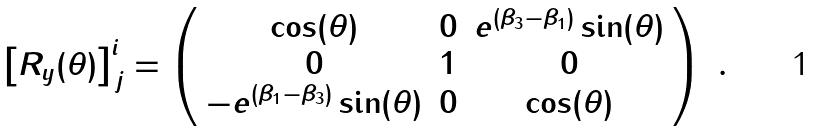Convert formula to latex. <formula><loc_0><loc_0><loc_500><loc_500>\left [ R _ { y } ( \theta ) \right ] ^ { i } _ { \, j } = \left ( \begin{array} { c c c } \cos ( \theta ) & 0 & e ^ { ( \beta _ { 3 } - \beta _ { 1 } ) } \sin ( \theta ) \\ 0 & 1 & 0 \\ - e ^ { ( \beta _ { 1 } - \beta _ { 3 } ) } \sin ( \theta ) & 0 & \cos ( \theta ) \end{array} \right ) \ .</formula> 